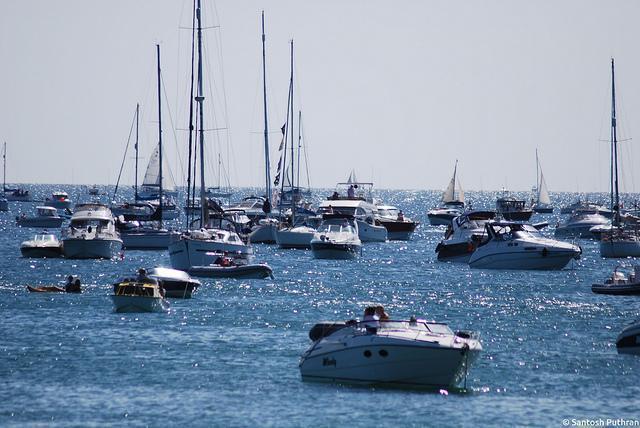Why do some boats have a big pole sticking up from it?
Select the accurate answer and provide justification: `Answer: choice
Rationale: srationale.`
Options: For sails, for navigation, send sos, for lookout. Answer: for sails.
Rationale: This pole is used to hold their sails up when they put them up. 